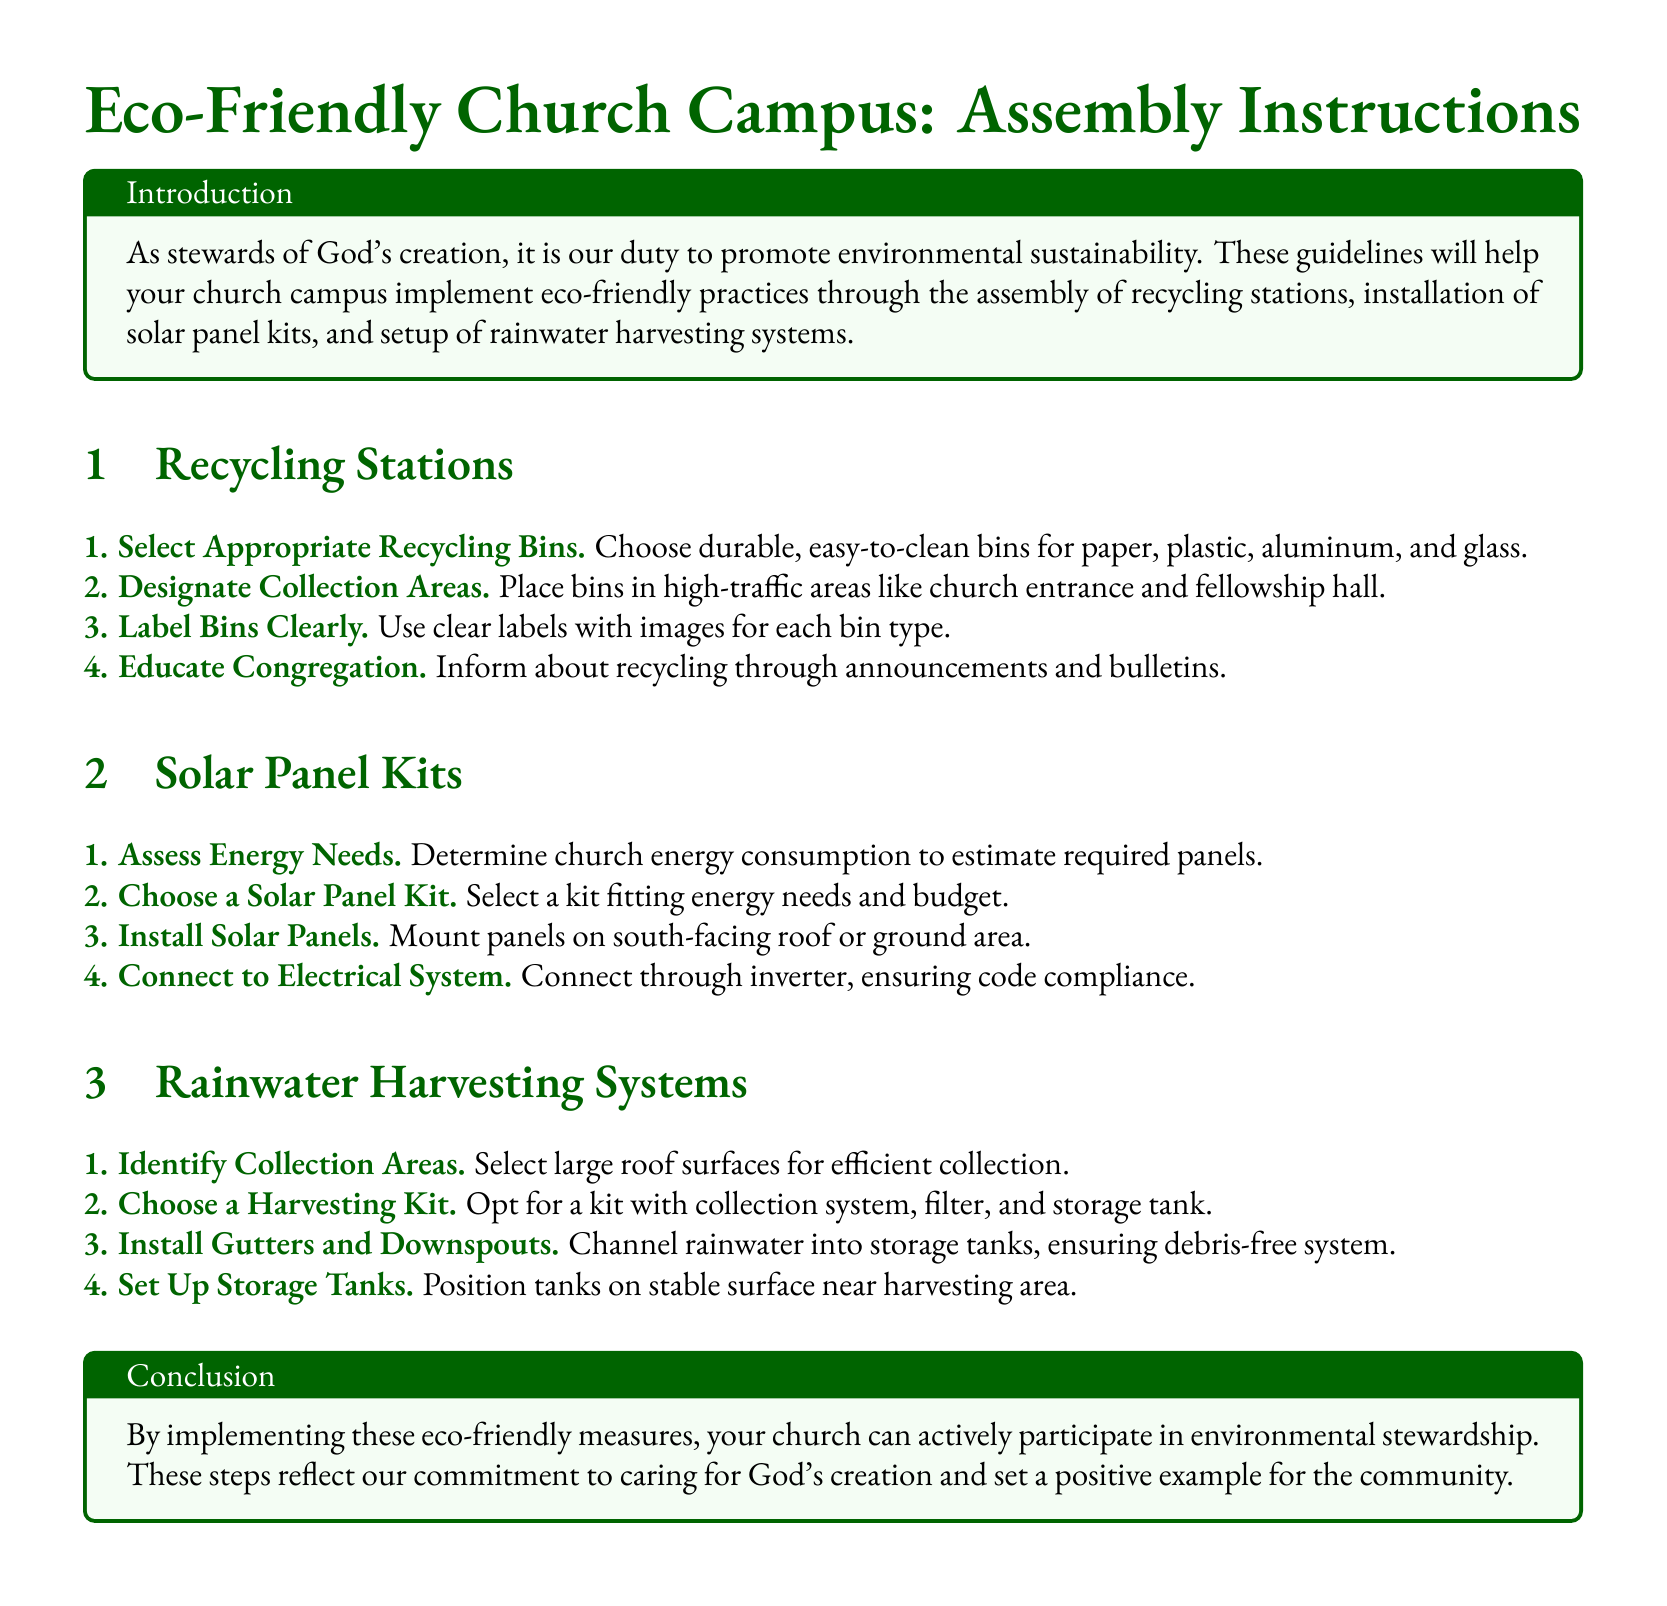What are the three eco-friendly practices mentioned? The document outlines recycling stations, solar panel kits, and rainwater harvesting systems as eco-friendly practices.
Answer: recycling stations, solar panel kits, rainwater harvesting systems Where should recycling bins be placed? The document states that recycling bins should be placed in high-traffic areas like the church entrance and fellowship hall.
Answer: high-traffic areas What type of bins should be chosen for recycling? It specifies that durable, easy-to-clean bins are to be chosen for recycling purposes.
Answer: durable, easy-to-clean bins How many steps are there for installing solar panels? The section on solar panel kits contains four specific steps for installation.
Answer: 4 What is the first step in setting up rainwater harvesting systems? The first step mentioned is to identify collection areas for efficient collection of rainwater.
Answer: Identify Collection Areas What should be included in the harvesting kit? The document notes that a harvesting kit should have a collection system, filter, and storage tank included.
Answer: collection system, filter, storage tank How can the congregation be educated about recycling? The document suggests informing the congregation through announcements and bulletins as a method of education.
Answer: announcements and bulletins What color is used for section titles? The section titles are described as using the color dark green in the document.
Answer: dark green 